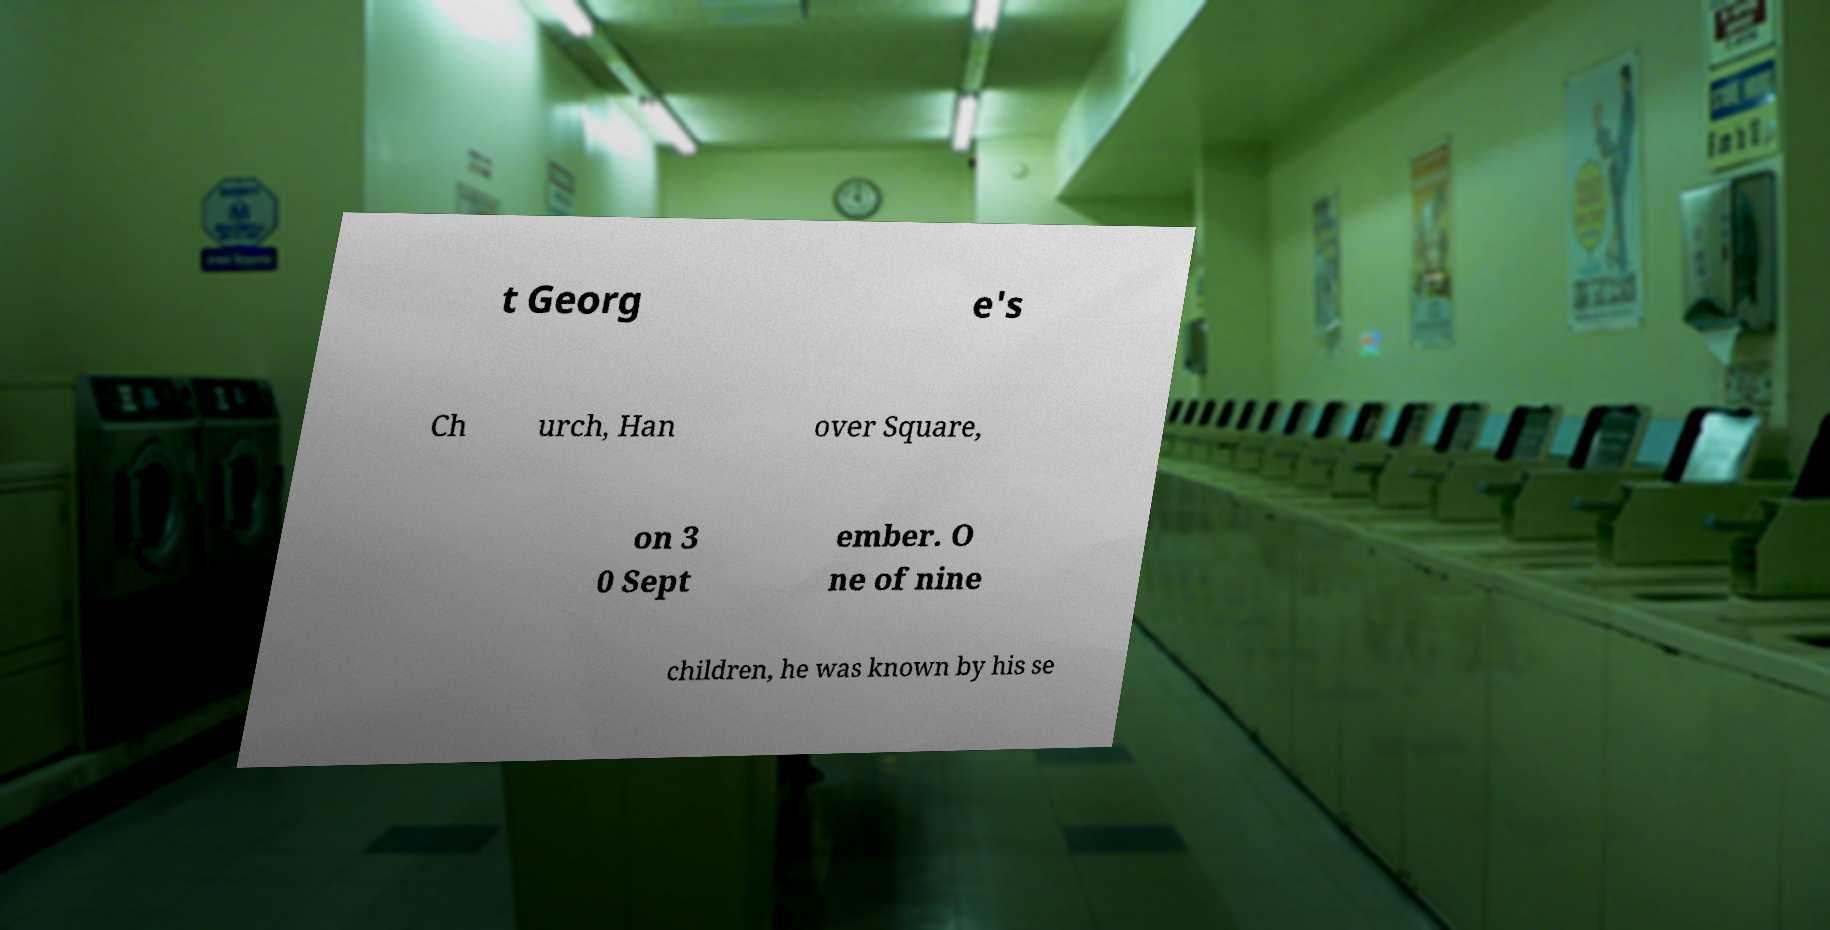What messages or text are displayed in this image? I need them in a readable, typed format. t Georg e's Ch urch, Han over Square, on 3 0 Sept ember. O ne of nine children, he was known by his se 